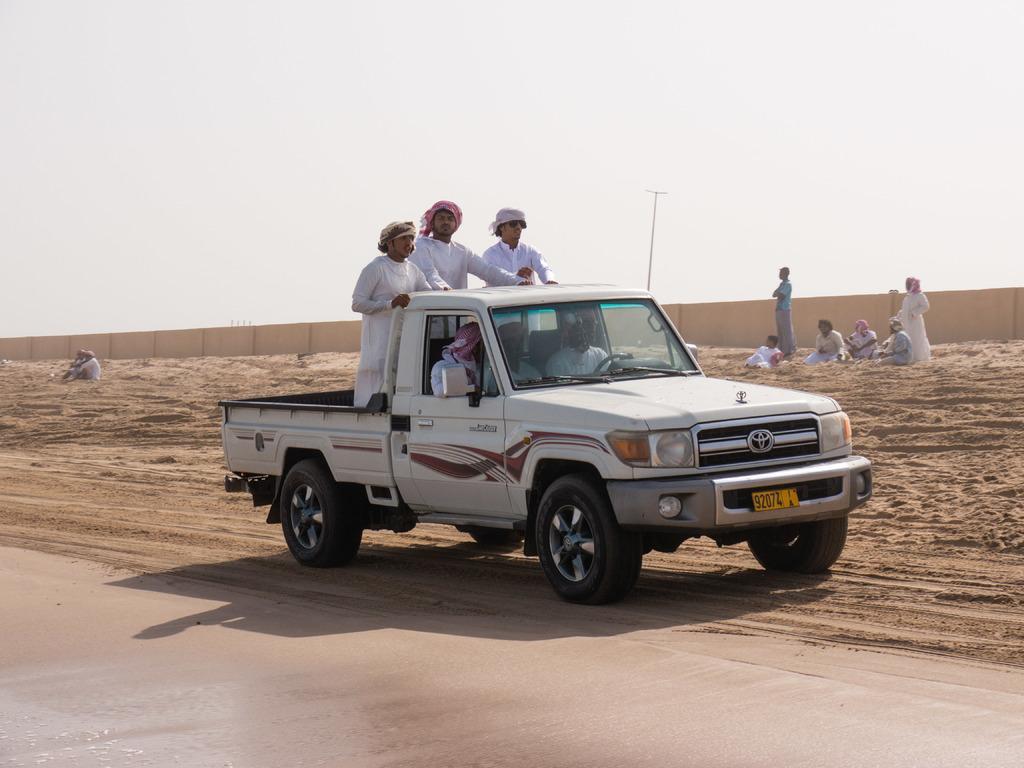Can you describe this image briefly? In the image there is a vehicle. Inside the vehicle there are few people sitting and also there are three persons standing. Behind them on the ground there are few people. In the background there is a fencing wall. At the top of the image there is sky.  